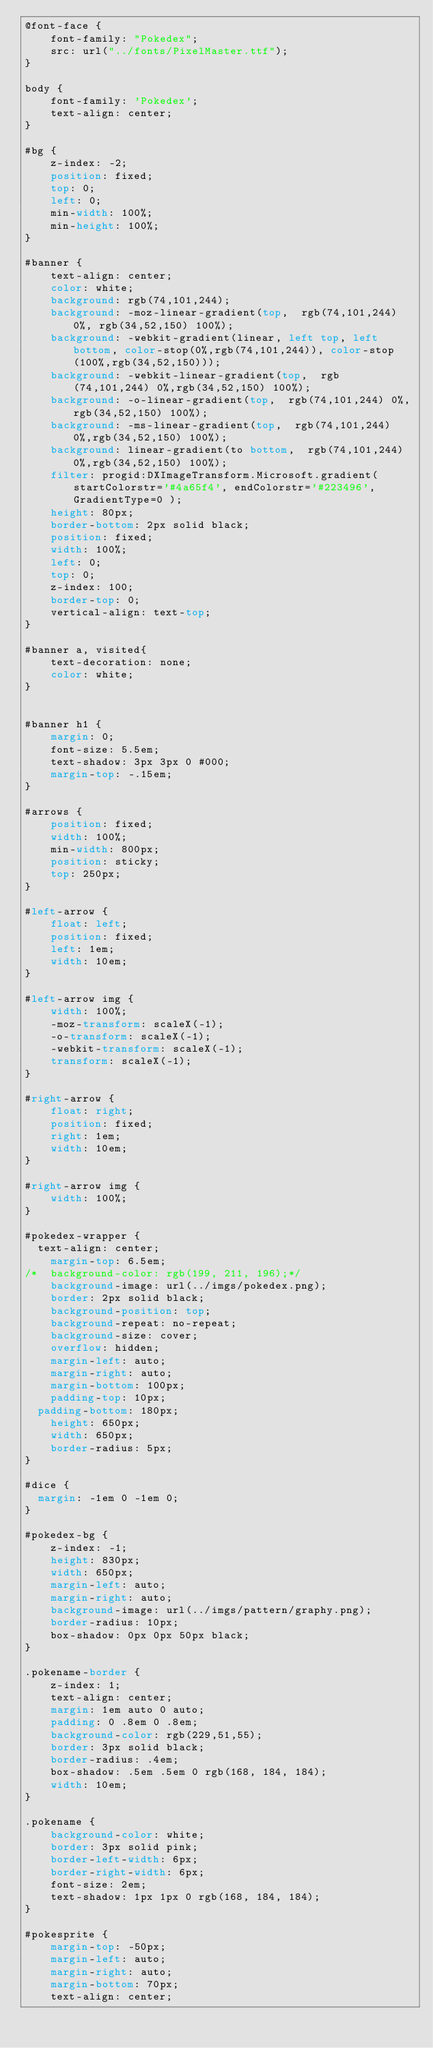Convert code to text. <code><loc_0><loc_0><loc_500><loc_500><_CSS_>@font-face {
	font-family: "Pokedex";
	src: url("../fonts/PixelMaster.ttf");
}

body {
	font-family: 'Pokedex';
	text-align: center;
}

#bg {
	z-index: -2;
	position: fixed;
	top: 0;
	left: 0;
	min-width: 100%;
	min-height: 100%;
}

#banner {
	text-align: center;
	color: white;
	background: rgb(74,101,244);
	background: -moz-linear-gradient(top,  rgb(74,101,244) 0%, rgb(34,52,150) 100%);
	background: -webkit-gradient(linear, left top, left bottom, color-stop(0%,rgb(74,101,244)), color-stop(100%,rgb(34,52,150)));
	background: -webkit-linear-gradient(top,  rgb(74,101,244) 0%,rgb(34,52,150) 100%);
	background: -o-linear-gradient(top,  rgb(74,101,244) 0%,rgb(34,52,150) 100%);
	background: -ms-linear-gradient(top,  rgb(74,101,244) 0%,rgb(34,52,150) 100%);
	background: linear-gradient(to bottom,  rgb(74,101,244) 0%,rgb(34,52,150) 100%);
	filter: progid:DXImageTransform.Microsoft.gradient( startColorstr='#4a65f4', endColorstr='#223496',GradientType=0 );
	height: 80px;
	border-bottom: 2px solid black;
	position: fixed;
	width: 100%;  
	left: 0;  
	top: 0;  
	z-index: 100;  
	border-top: 0;
	vertical-align: text-top;
}

#banner a, visited{
	text-decoration: none;
	color: white;
}


#banner h1 {
	margin: 0;
	font-size: 5.5em;
	text-shadow: 3px 3px 0 #000;
	margin-top: -.15em;
}

#arrows {
	position: fixed;
	width: 100%;
	min-width: 800px;
	position: sticky;
	top: 250px;
}

#left-arrow {
	float: left;
	position: fixed;
	left: 1em;
	width: 10em;
}

#left-arrow img {
	width: 100%;
	-moz-transform: scaleX(-1);
	-o-transform: scaleX(-1);
	-webkit-transform: scaleX(-1);
	transform: scaleX(-1);
}

#right-arrow {
	float: right;
	position: fixed;
	right: 1em;
	width: 10em;
}

#right-arrow img {
	width: 100%;
}

#pokedex-wrapper {
  text-align: center;
	margin-top: 6.5em;
/*	background-color: rgb(199, 211, 196);*/
	background-image: url(../imgs/pokedex.png);
	border: 2px solid black;
	background-position: top;
	background-repeat: no-repeat;
	background-size: cover;
	overflow: hidden;
	margin-left: auto;
	margin-right: auto;
	margin-bottom: 100px;
	padding-top: 10px;
  padding-bottom: 180px;
	height: 650px;
	width: 650px;
	border-radius: 5px;
}

#dice {
  margin: -1em 0 -1em 0;
}

#pokedex-bg {
	z-index: -1;
	height: 830px;
	width: 650px;
	margin-left: auto;
	margin-right: auto;
	background-image: url(../imgs/pattern/graphy.png);
	border-radius: 10px;
	box-shadow: 0px 0px 50px black;
}

.pokename-border {
	z-index: 1;
	text-align: center;
	margin: 1em auto 0 auto;
	padding: 0 .8em 0 .8em;
	background-color: rgb(229,51,55);
	border: 3px solid black;
	border-radius: .4em;
	box-shadow: .5em .5em 0 rgb(168, 184, 184);
	width: 10em;
}

.pokename {
	background-color: white;
	border: 3px solid pink;
	border-left-width: 6px;
	border-right-width: 6px;
	font-size: 2em;
	text-shadow: 1px 1px 0 rgb(168, 184, 184);
}

#pokesprite {
	margin-top: -50px;
	margin-left: auto;
	margin-right: auto;
  	margin-bottom: 70px;
	text-align: center;</code> 